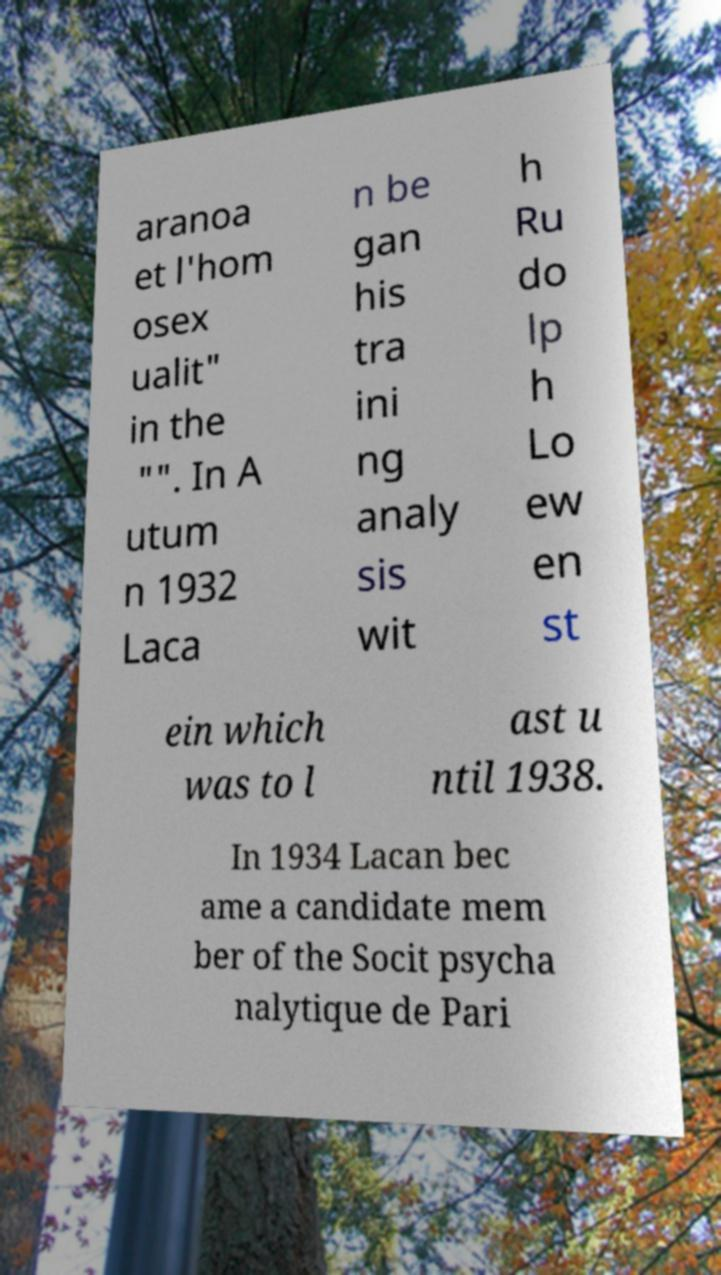There's text embedded in this image that I need extracted. Can you transcribe it verbatim? aranoa et l'hom osex ualit" in the "". In A utum n 1932 Laca n be gan his tra ini ng analy sis wit h Ru do lp h Lo ew en st ein which was to l ast u ntil 1938. In 1934 Lacan bec ame a candidate mem ber of the Socit psycha nalytique de Pari 